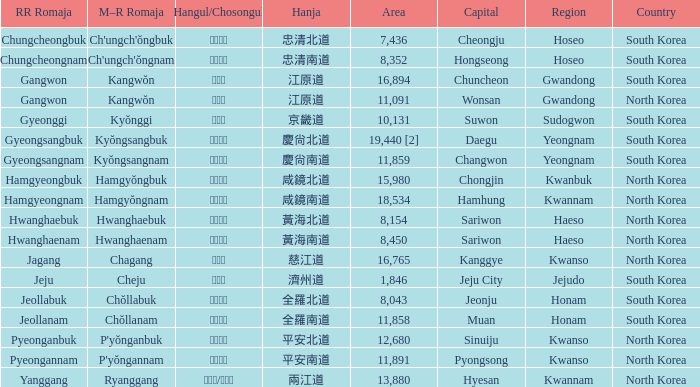Which city, serving as a capital, has the hangul 경상남도? Changwon. 